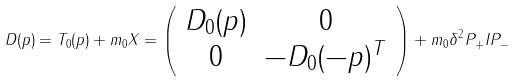<formula> <loc_0><loc_0><loc_500><loc_500>D ( p ) = T _ { 0 } ( p ) + m _ { 0 } X = \left ( \begin{array} { c c } D _ { 0 } ( p ) & 0 \\ 0 & - D _ { 0 } ( - p ) ^ { T } \end{array} \right ) + m _ { 0 } \delta ^ { 2 } P _ { + } I P _ { - }</formula> 